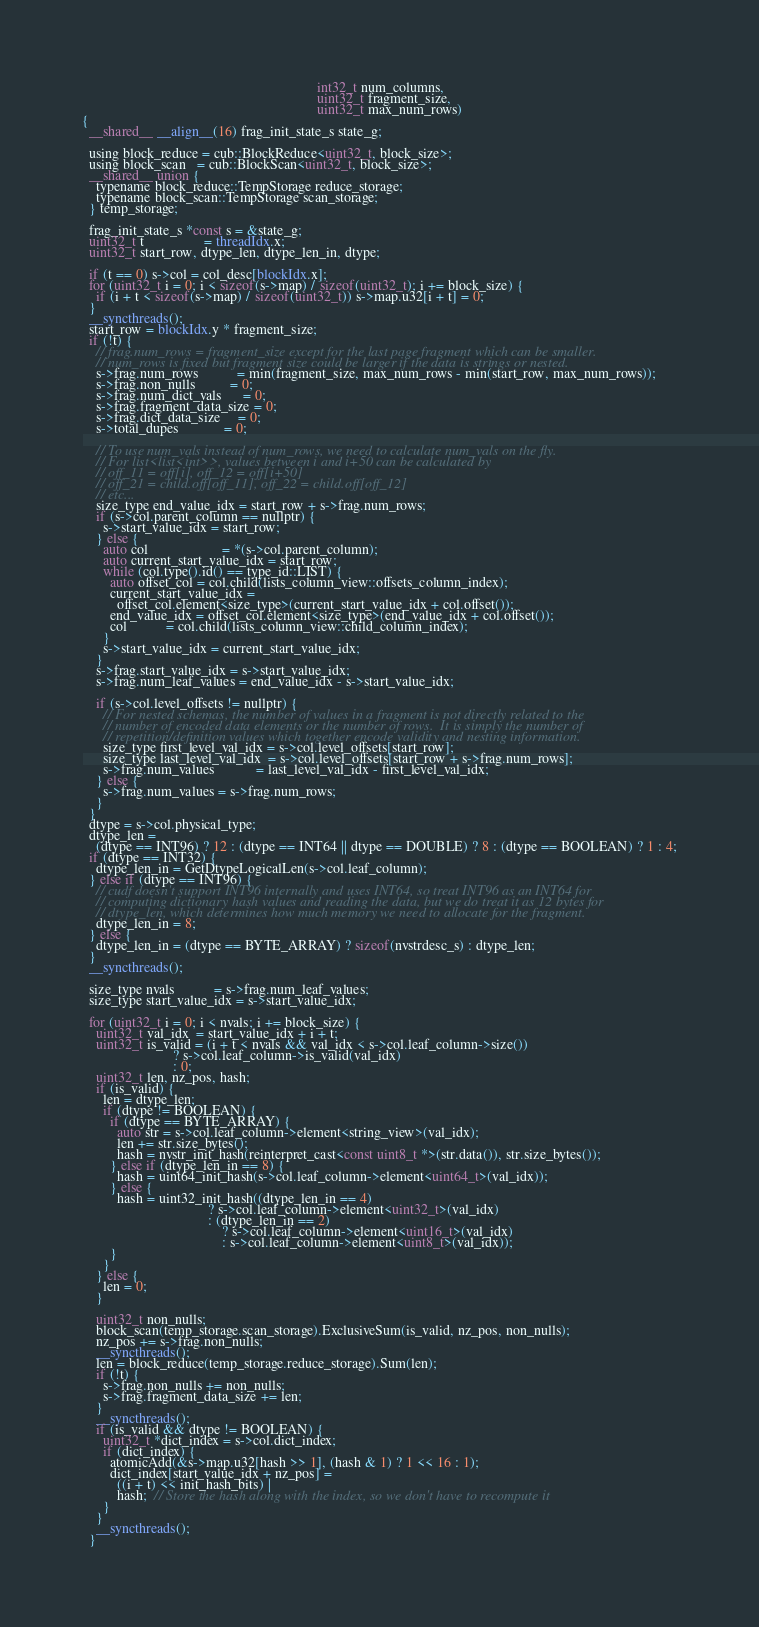<code> <loc_0><loc_0><loc_500><loc_500><_Cuda_>                                                                   int32_t num_columns,
                                                                   uint32_t fragment_size,
                                                                   uint32_t max_num_rows)
{
  __shared__ __align__(16) frag_init_state_s state_g;

  using block_reduce = cub::BlockReduce<uint32_t, block_size>;
  using block_scan   = cub::BlockScan<uint32_t, block_size>;
  __shared__ union {
    typename block_reduce::TempStorage reduce_storage;
    typename block_scan::TempStorage scan_storage;
  } temp_storage;

  frag_init_state_s *const s = &state_g;
  uint32_t t                 = threadIdx.x;
  uint32_t start_row, dtype_len, dtype_len_in, dtype;

  if (t == 0) s->col = col_desc[blockIdx.x];
  for (uint32_t i = 0; i < sizeof(s->map) / sizeof(uint32_t); i += block_size) {
    if (i + t < sizeof(s->map) / sizeof(uint32_t)) s->map.u32[i + t] = 0;
  }
  __syncthreads();
  start_row = blockIdx.y * fragment_size;
  if (!t) {
    // frag.num_rows = fragment_size except for the last page fragment which can be smaller.
    // num_rows is fixed but fragment size could be larger if the data is strings or nested.
    s->frag.num_rows           = min(fragment_size, max_num_rows - min(start_row, max_num_rows));
    s->frag.non_nulls          = 0;
    s->frag.num_dict_vals      = 0;
    s->frag.fragment_data_size = 0;
    s->frag.dict_data_size     = 0;
    s->total_dupes             = 0;

    // To use num_vals instead of num_rows, we need to calculate num_vals on the fly.
    // For list<list<int>>, values between i and i+50 can be calculated by
    // off_11 = off[i], off_12 = off[i+50]
    // off_21 = child.off[off_11], off_22 = child.off[off_12]
    // etc...
    size_type end_value_idx = start_row + s->frag.num_rows;
    if (s->col.parent_column == nullptr) {
      s->start_value_idx = start_row;
    } else {
      auto col                     = *(s->col.parent_column);
      auto current_start_value_idx = start_row;
      while (col.type().id() == type_id::LIST) {
        auto offset_col = col.child(lists_column_view::offsets_column_index);
        current_start_value_idx =
          offset_col.element<size_type>(current_start_value_idx + col.offset());
        end_value_idx = offset_col.element<size_type>(end_value_idx + col.offset());
        col           = col.child(lists_column_view::child_column_index);
      }
      s->start_value_idx = current_start_value_idx;
    }
    s->frag.start_value_idx = s->start_value_idx;
    s->frag.num_leaf_values = end_value_idx - s->start_value_idx;

    if (s->col.level_offsets != nullptr) {
      // For nested schemas, the number of values in a fragment is not directly related to the
      // number of encoded data elements or the number of rows.  It is simply the number of
      // repetition/definition values which together encode validity and nesting information.
      size_type first_level_val_idx = s->col.level_offsets[start_row];
      size_type last_level_val_idx  = s->col.level_offsets[start_row + s->frag.num_rows];
      s->frag.num_values            = last_level_val_idx - first_level_val_idx;
    } else {
      s->frag.num_values = s->frag.num_rows;
    }
  }
  dtype = s->col.physical_type;
  dtype_len =
    (dtype == INT96) ? 12 : (dtype == INT64 || dtype == DOUBLE) ? 8 : (dtype == BOOLEAN) ? 1 : 4;
  if (dtype == INT32) {
    dtype_len_in = GetDtypeLogicalLen(s->col.leaf_column);
  } else if (dtype == INT96) {
    // cudf doesn't support INT96 internally and uses INT64, so treat INT96 as an INT64 for
    // computing dictionary hash values and reading the data, but we do treat it as 12 bytes for
    // dtype_len, which determines how much memory we need to allocate for the fragment.
    dtype_len_in = 8;
  } else {
    dtype_len_in = (dtype == BYTE_ARRAY) ? sizeof(nvstrdesc_s) : dtype_len;
  }
  __syncthreads();

  size_type nvals           = s->frag.num_leaf_values;
  size_type start_value_idx = s->start_value_idx;

  for (uint32_t i = 0; i < nvals; i += block_size) {
    uint32_t val_idx  = start_value_idx + i + t;
    uint32_t is_valid = (i + t < nvals && val_idx < s->col.leaf_column->size())
                          ? s->col.leaf_column->is_valid(val_idx)
                          : 0;
    uint32_t len, nz_pos, hash;
    if (is_valid) {
      len = dtype_len;
      if (dtype != BOOLEAN) {
        if (dtype == BYTE_ARRAY) {
          auto str = s->col.leaf_column->element<string_view>(val_idx);
          len += str.size_bytes();
          hash = nvstr_init_hash(reinterpret_cast<const uint8_t *>(str.data()), str.size_bytes());
        } else if (dtype_len_in == 8) {
          hash = uint64_init_hash(s->col.leaf_column->element<uint64_t>(val_idx));
        } else {
          hash = uint32_init_hash((dtype_len_in == 4)
                                    ? s->col.leaf_column->element<uint32_t>(val_idx)
                                    : (dtype_len_in == 2)
                                        ? s->col.leaf_column->element<uint16_t>(val_idx)
                                        : s->col.leaf_column->element<uint8_t>(val_idx));
        }
      }
    } else {
      len = 0;
    }

    uint32_t non_nulls;
    block_scan(temp_storage.scan_storage).ExclusiveSum(is_valid, nz_pos, non_nulls);
    nz_pos += s->frag.non_nulls;
    __syncthreads();
    len = block_reduce(temp_storage.reduce_storage).Sum(len);
    if (!t) {
      s->frag.non_nulls += non_nulls;
      s->frag.fragment_data_size += len;
    }
    __syncthreads();
    if (is_valid && dtype != BOOLEAN) {
      uint32_t *dict_index = s->col.dict_index;
      if (dict_index) {
        atomicAdd(&s->map.u32[hash >> 1], (hash & 1) ? 1 << 16 : 1);
        dict_index[start_value_idx + nz_pos] =
          ((i + t) << init_hash_bits) |
          hash;  // Store the hash along with the index, so we don't have to recompute it
      }
    }
    __syncthreads();
  }</code> 